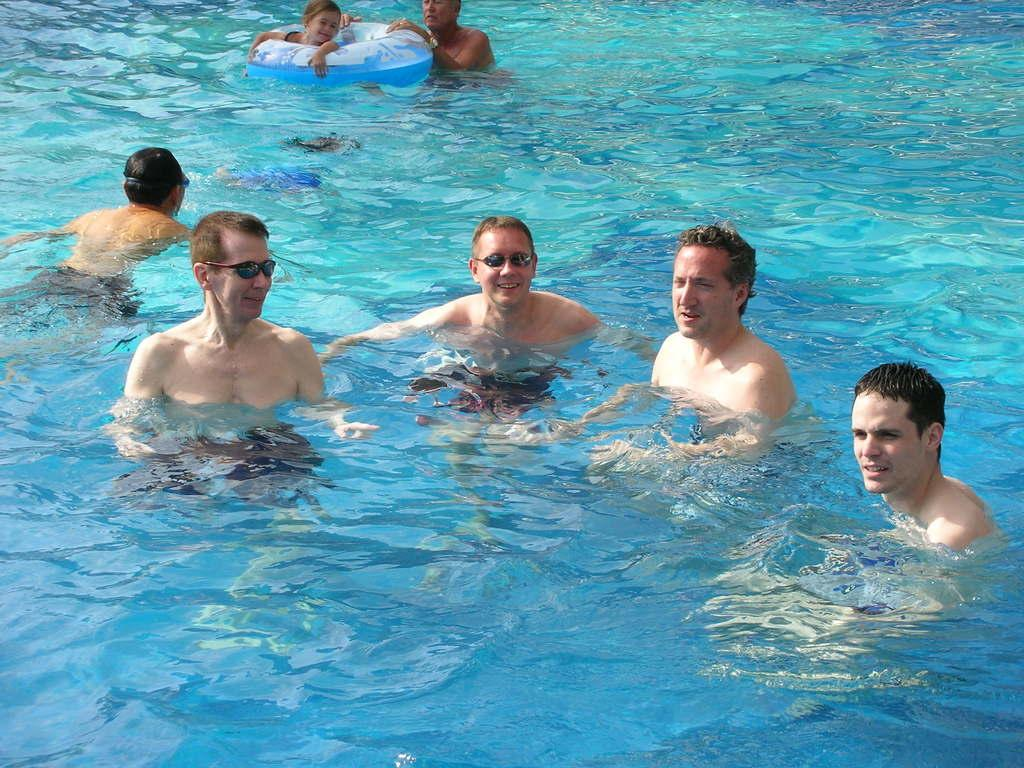What are the people in the water doing in the image? The people in the water are swimming. How many people are swimming in the water? There are four people swimming in the water: three men and one girl. How is the girl swimming differently from the men? The girl is using a balloon to swim. Who is holding the balloon for the girl? There is a person holding the balloon for the girl. What type of eggs can be seen in the image? There are no eggs present in the image. How does the quiet environment affect the swimmers in the image? The image does not provide information about the noise level or environment, so it cannot be determined how the quiet environment affects the swimmers. 